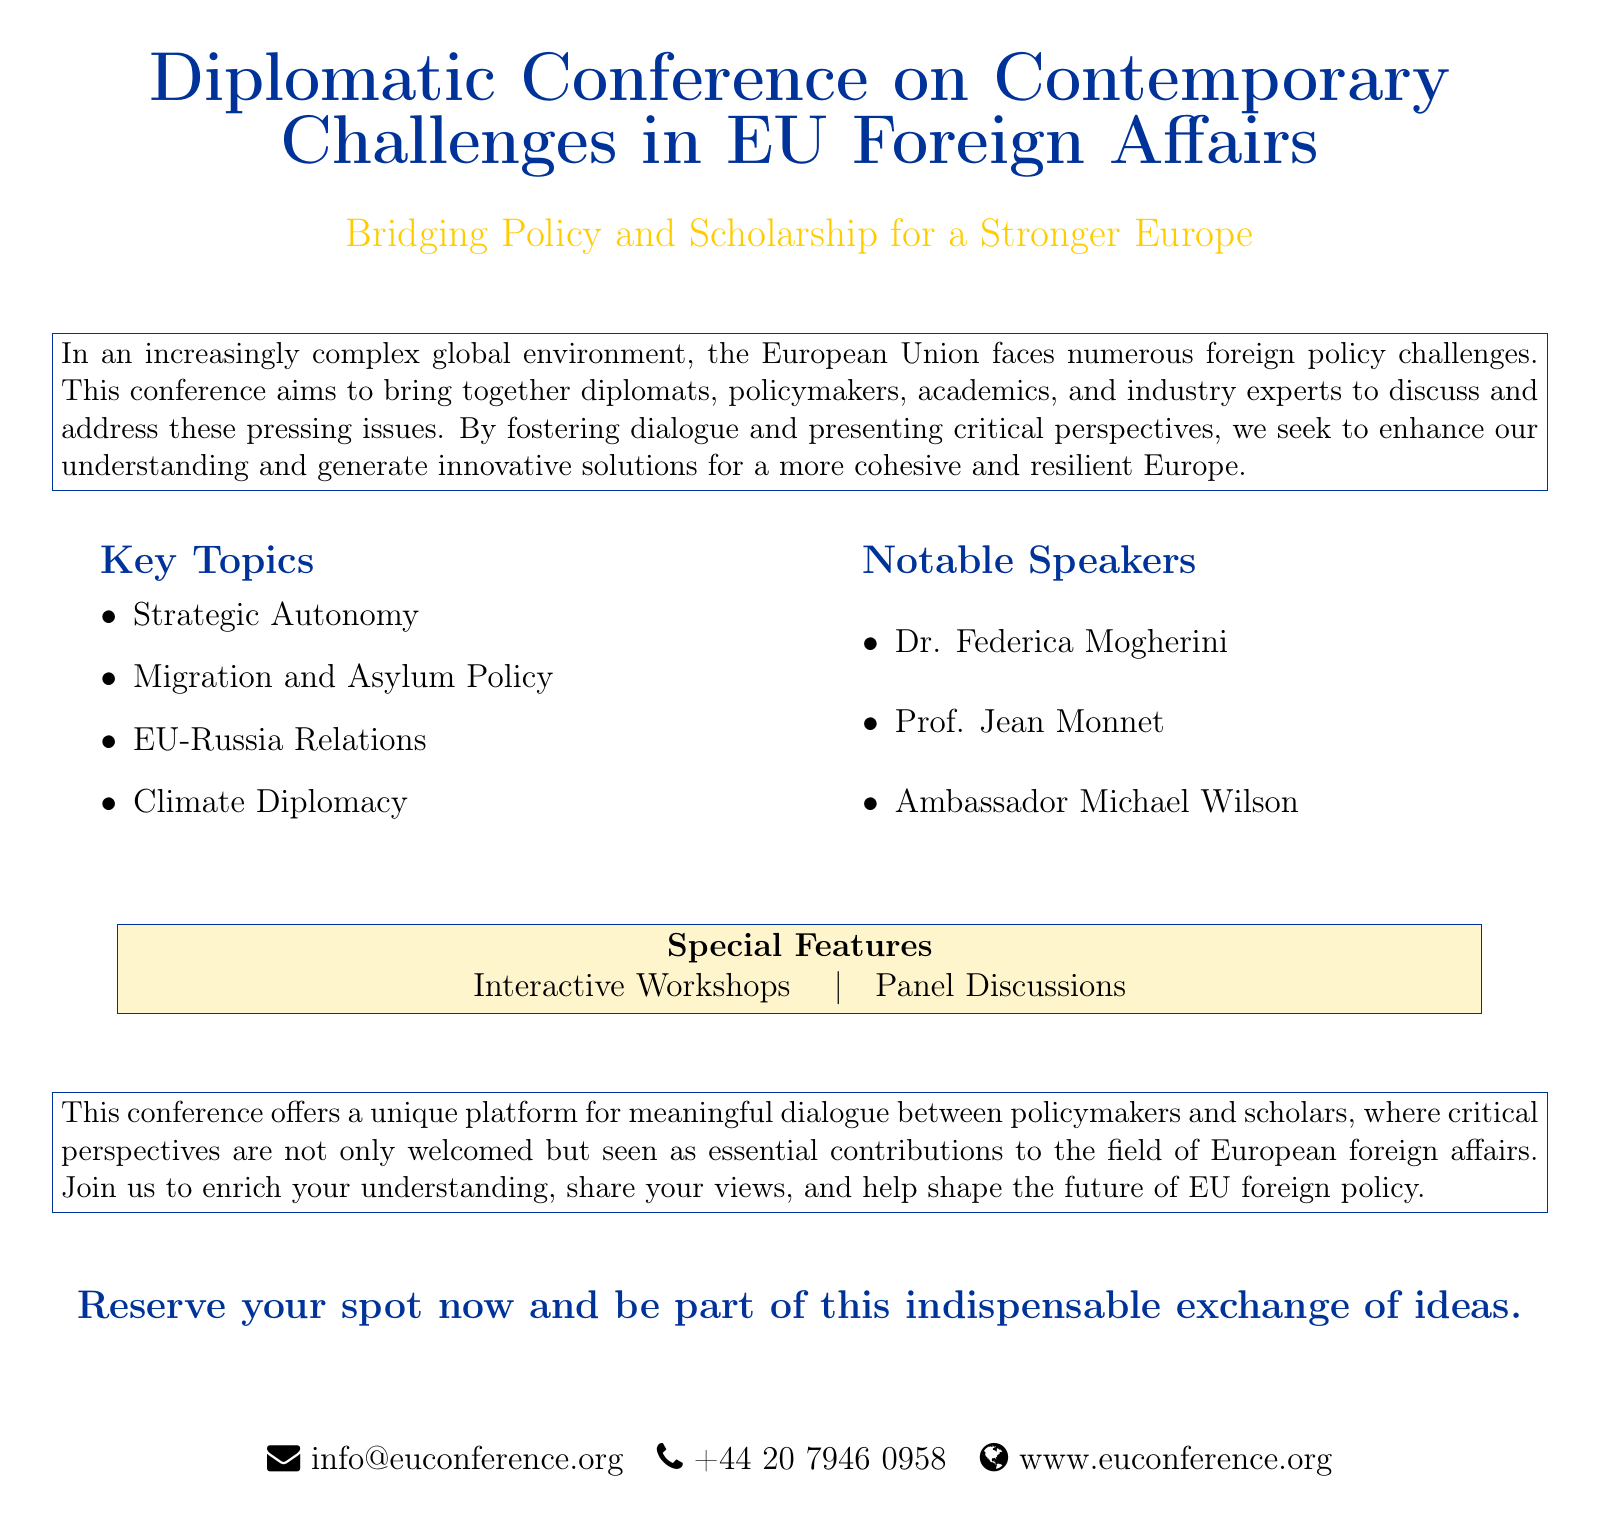What is the title of the conference? The title of the conference is stated at the beginning of the document, which is "Diplomatic Conference on Contemporary Challenges in EU Foreign Affairs."
Answer: Diplomatic Conference on Contemporary Challenges in EU Foreign Affairs What are the key topics discussed at the conference? The key topics are listed in a bullet point format, including Strategic Autonomy, Migration and Asylum Policy, EU-Russia Relations, and Climate Diplomacy.
Answer: Strategic Autonomy, Migration and Asylum Policy, EU-Russia Relations, Climate Diplomacy Who is one of the notable speakers? The names of notable speakers are provided in a list, where Dr. Federica Mogherini is mentioned as one of them.
Answer: Dr. Federica Mogherini What special features does the conference offer? The special features are highlighted in a section of the document, listing "Interactive Workshops" and "Panel Discussions."
Answer: Interactive Workshops, Panel Discussions What is the main goal of the conference according to the brochure? The goal of the conference is described as enhancing understanding and generating innovative solutions for a more cohesive and resilient Europe.
Answer: Enhance understanding and generate innovative solutions How can participants reserve their spot for the conference? The document indicates that potential participants should reserve their spot by contacting provided information.
Answer: Reserve your spot now What is emphasized as essential to the field of European foreign affairs? The document explicitly states that "critical perspectives" are essential contributions to the field.
Answer: Critical perspectives 